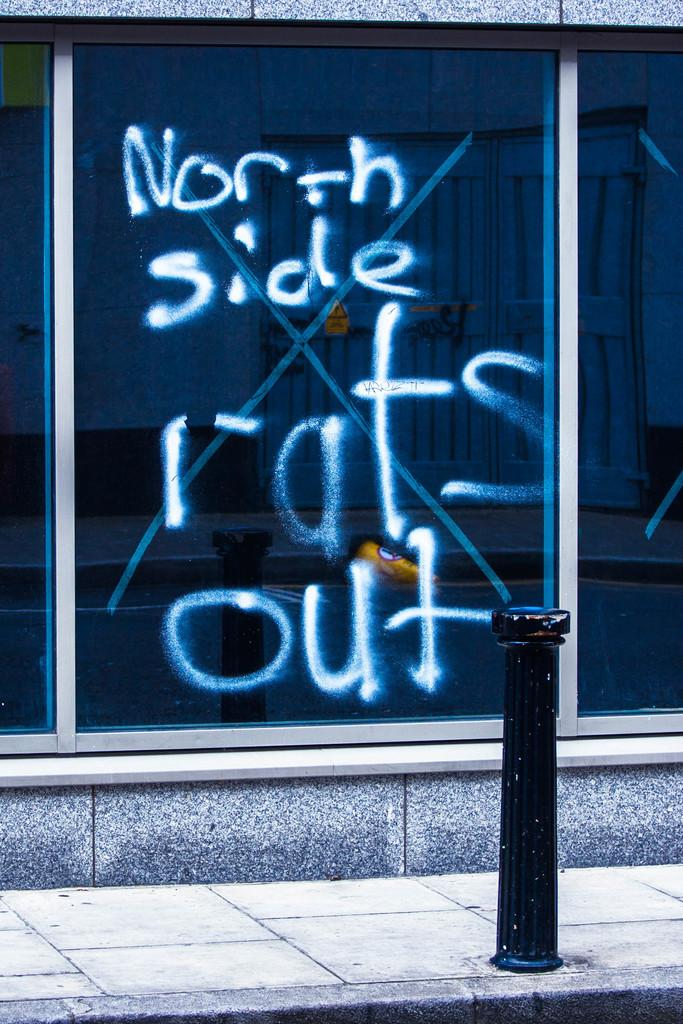What is written or displayed on a surface in the image? There is text on a window in the image. What can be seen on the road in the image? There is a barrier pole on the road in the image. Can you tell me how many buttons are on the woman's shirt in the image? There is no woman present in the image, so it is not possible to determine the number of buttons on her shirt. 